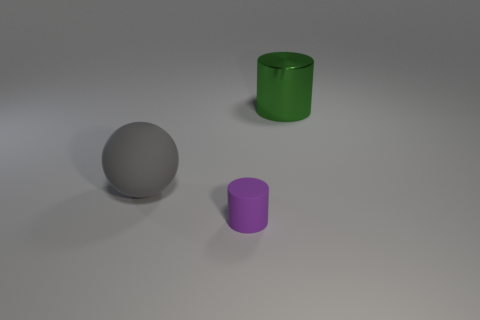How many balls are blue things or big metallic things?
Make the answer very short. 0. Are there fewer gray matte balls that are behind the matte cylinder than big green objects?
Give a very brief answer. No. How many other objects are the same material as the tiny thing?
Offer a very short reply. 1. Is the size of the gray matte thing the same as the green shiny thing?
Provide a succinct answer. Yes. What number of things are rubber objects that are to the right of the sphere or green metallic things?
Your answer should be very brief. 2. The cylinder in front of the thing on the right side of the purple matte thing is made of what material?
Your response must be concise. Rubber. Is there another large thing of the same shape as the green object?
Ensure brevity in your answer.  No. Is the size of the metal cylinder the same as the matte object in front of the big gray ball?
Give a very brief answer. No. What number of objects are either rubber things in front of the large gray thing or objects that are left of the tiny purple rubber object?
Your response must be concise. 2. Are there more big shiny things to the left of the big gray matte object than small rubber spheres?
Your answer should be very brief. No. 